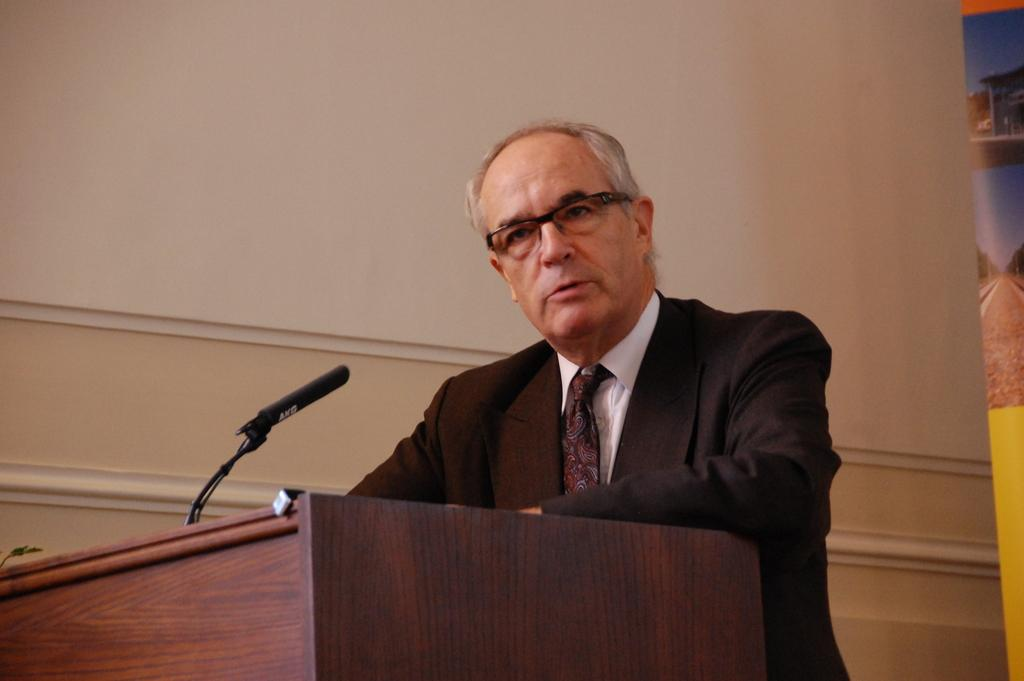What is the main subject of the image? There is a person in the image. What is the person wearing? The person is wearing a suit and spectacles. What is the person standing behind? The person is standing behind a wooden podium. What is on the wooden podium? There is a microphone on the wooden podium. What can be seen in the background of the image? There is a wall in the background of the image. What type of rings is the person wearing on their fingers in the image? There is no indication of any rings being worn by the person in the image. 